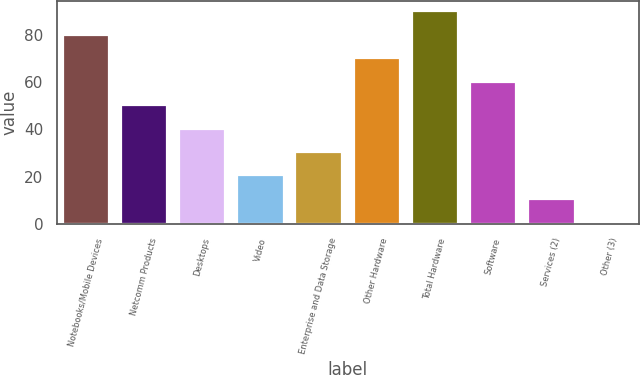Convert chart to OTSL. <chart><loc_0><loc_0><loc_500><loc_500><bar_chart><fcel>Notebooks/Mobile Devices<fcel>Netcomm Products<fcel>Desktops<fcel>Video<fcel>Enterprise and Data Storage<fcel>Other Hardware<fcel>Total Hardware<fcel>Software<fcel>Services (2)<fcel>Other (3)<nl><fcel>80.12<fcel>50.3<fcel>40.36<fcel>20.48<fcel>30.42<fcel>70.18<fcel>90.06<fcel>60.24<fcel>10.54<fcel>0.6<nl></chart> 